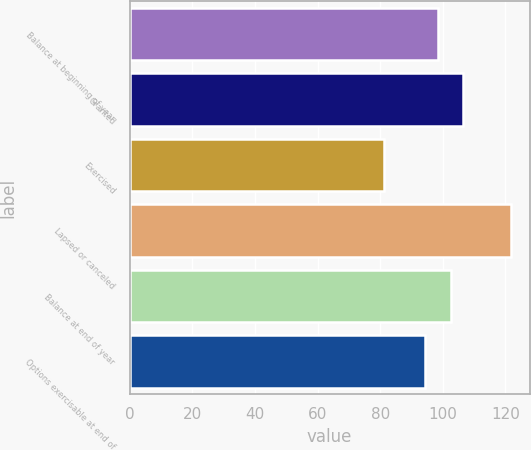<chart> <loc_0><loc_0><loc_500><loc_500><bar_chart><fcel>Balance at beginning of year<fcel>Granted<fcel>Exercised<fcel>Lapsed or canceled<fcel>Balance at end of year<fcel>Options exercisable at end of<nl><fcel>98.44<fcel>106.56<fcel>81.07<fcel>121.68<fcel>102.5<fcel>94.33<nl></chart> 